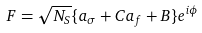Convert formula to latex. <formula><loc_0><loc_0><loc_500><loc_500>F = \sqrt { N _ { S } } \{ a _ { \sigma } + C a _ { f } + B \} e ^ { i \phi }</formula> 